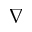<formula> <loc_0><loc_0><loc_500><loc_500>\nabla</formula> 